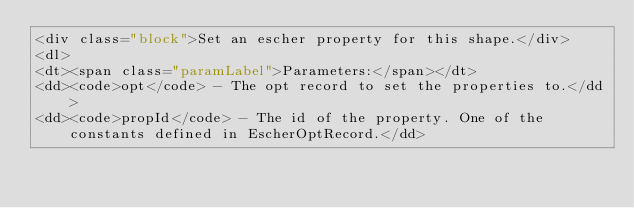Convert code to text. <code><loc_0><loc_0><loc_500><loc_500><_HTML_><div class="block">Set an escher property for this shape.</div>
<dl>
<dt><span class="paramLabel">Parameters:</span></dt>
<dd><code>opt</code> - The opt record to set the properties to.</dd>
<dd><code>propId</code> - The id of the property. One of the constants defined in EscherOptRecord.</dd></code> 